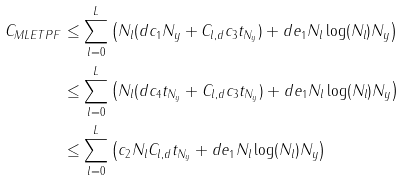<formula> <loc_0><loc_0><loc_500><loc_500>C _ { M L E T P F } & \leq \sum ^ { L } _ { l = 0 } \left ( N _ { l } ( d c _ { 1 } N _ { y } + C _ { l , d } c _ { 3 } t _ { N _ { y } } ) + d e _ { 1 } N _ { l } \log ( N _ { l } ) N _ { y } \right ) \\ & \leq \sum ^ { L } _ { l = 0 } \left ( N _ { l } ( d c _ { 4 } t _ { N _ { y } } + C _ { l , d } c _ { 3 } t _ { N _ { y } } ) + d e _ { 1 } N _ { l } \log ( N _ { l } ) N _ { y } \right ) \\ & \leq \sum ^ { L } _ { l = 0 } \left ( c _ { 2 } N _ { l } C _ { l , d } t _ { N _ { y } } + d e _ { 1 } N _ { l } \log ( N _ { l } ) N _ { y } \right )</formula> 